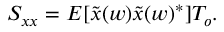<formula> <loc_0><loc_0><loc_500><loc_500>S _ { x x } = E [ { \tilde { x } } ( w ) \tilde { x } ( w ) ^ { * } ] T _ { o } .</formula> 